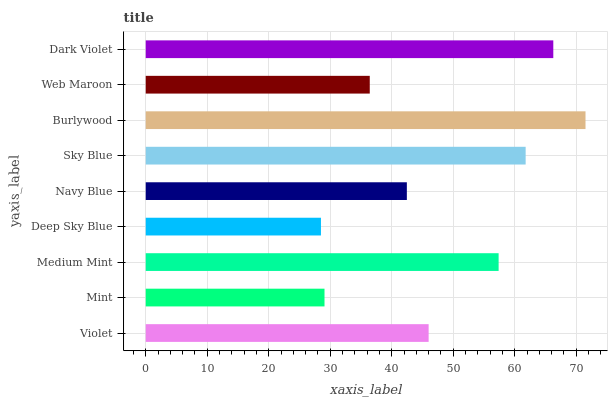Is Deep Sky Blue the minimum?
Answer yes or no. Yes. Is Burlywood the maximum?
Answer yes or no. Yes. Is Mint the minimum?
Answer yes or no. No. Is Mint the maximum?
Answer yes or no. No. Is Violet greater than Mint?
Answer yes or no. Yes. Is Mint less than Violet?
Answer yes or no. Yes. Is Mint greater than Violet?
Answer yes or no. No. Is Violet less than Mint?
Answer yes or no. No. Is Violet the high median?
Answer yes or no. Yes. Is Violet the low median?
Answer yes or no. Yes. Is Deep Sky Blue the high median?
Answer yes or no. No. Is Medium Mint the low median?
Answer yes or no. No. 